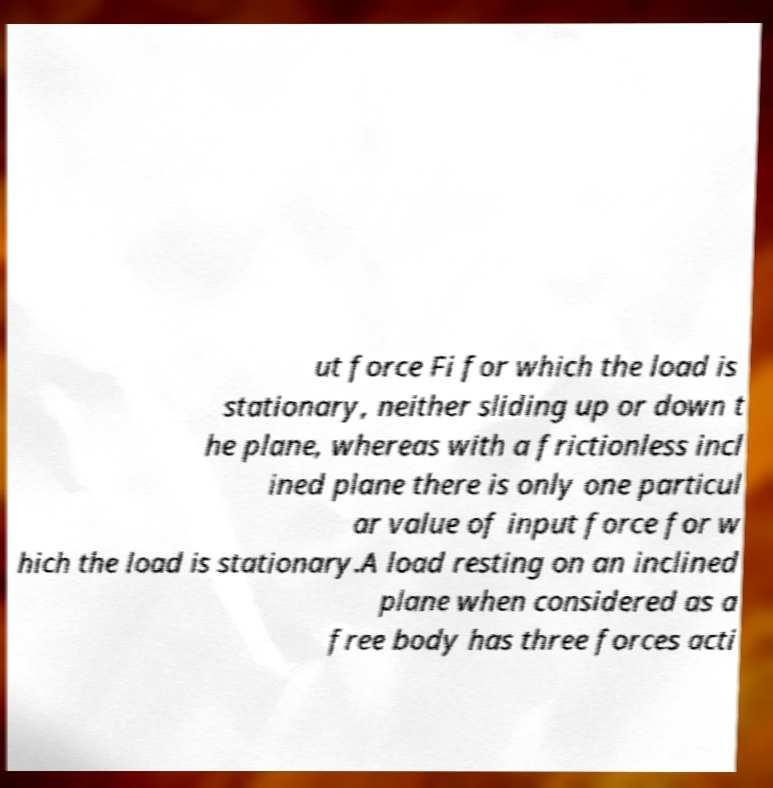For documentation purposes, I need the text within this image transcribed. Could you provide that? ut force Fi for which the load is stationary, neither sliding up or down t he plane, whereas with a frictionless incl ined plane there is only one particul ar value of input force for w hich the load is stationary.A load resting on an inclined plane when considered as a free body has three forces acti 